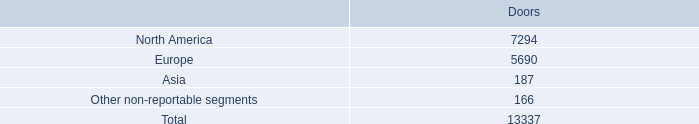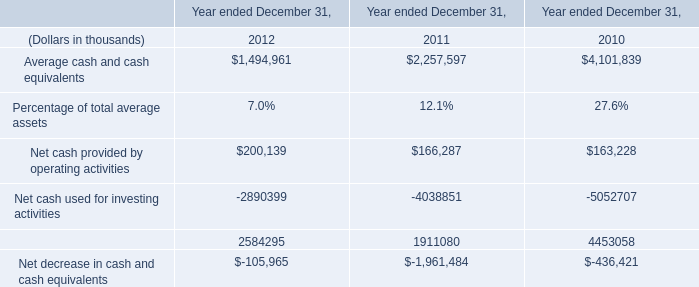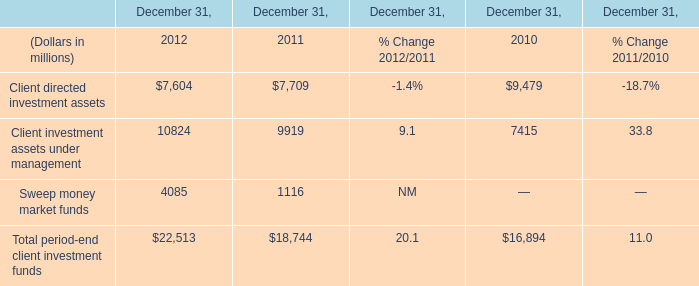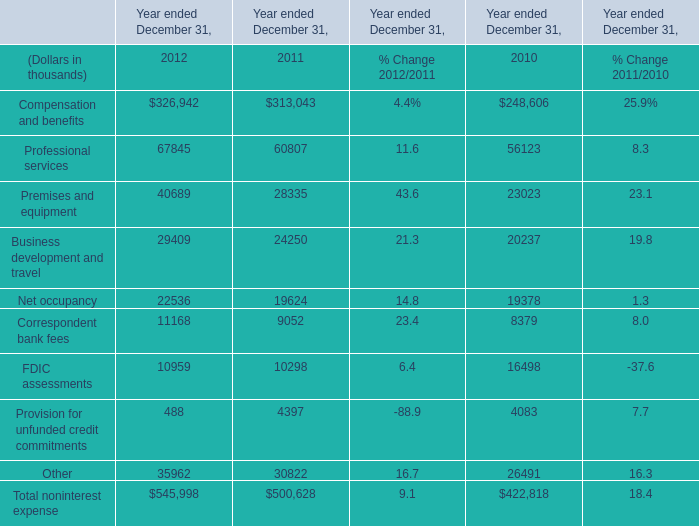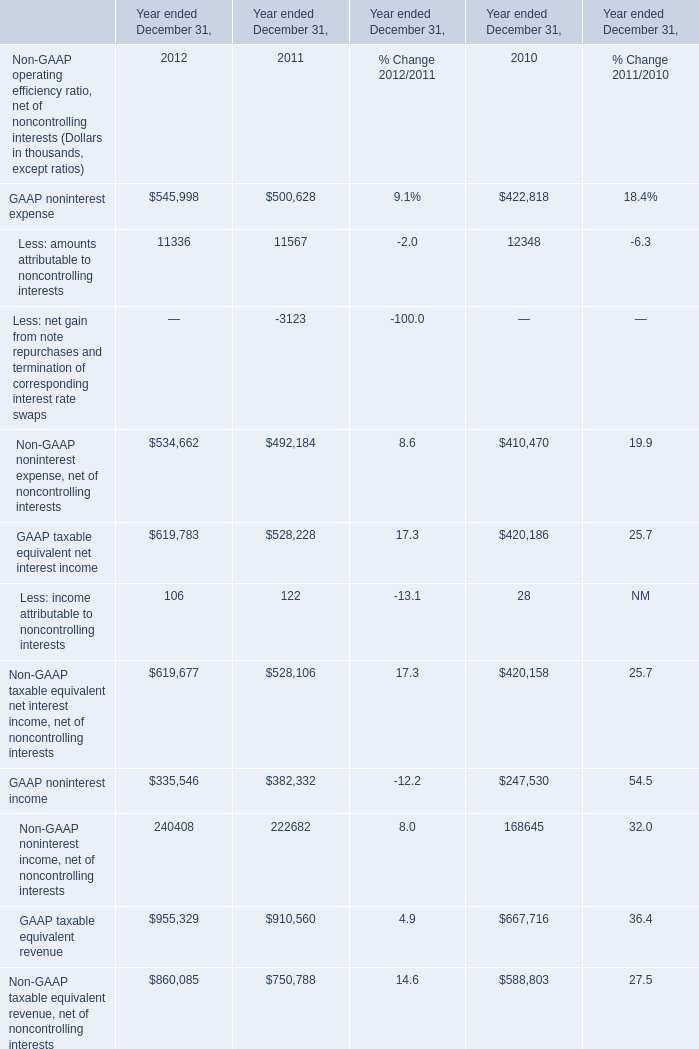what's the total amount of North America of Doors, and Client investment assets under management of December 31, 2011 ? 
Computations: (7294.0 + 9919.0)
Answer: 17213.0. 